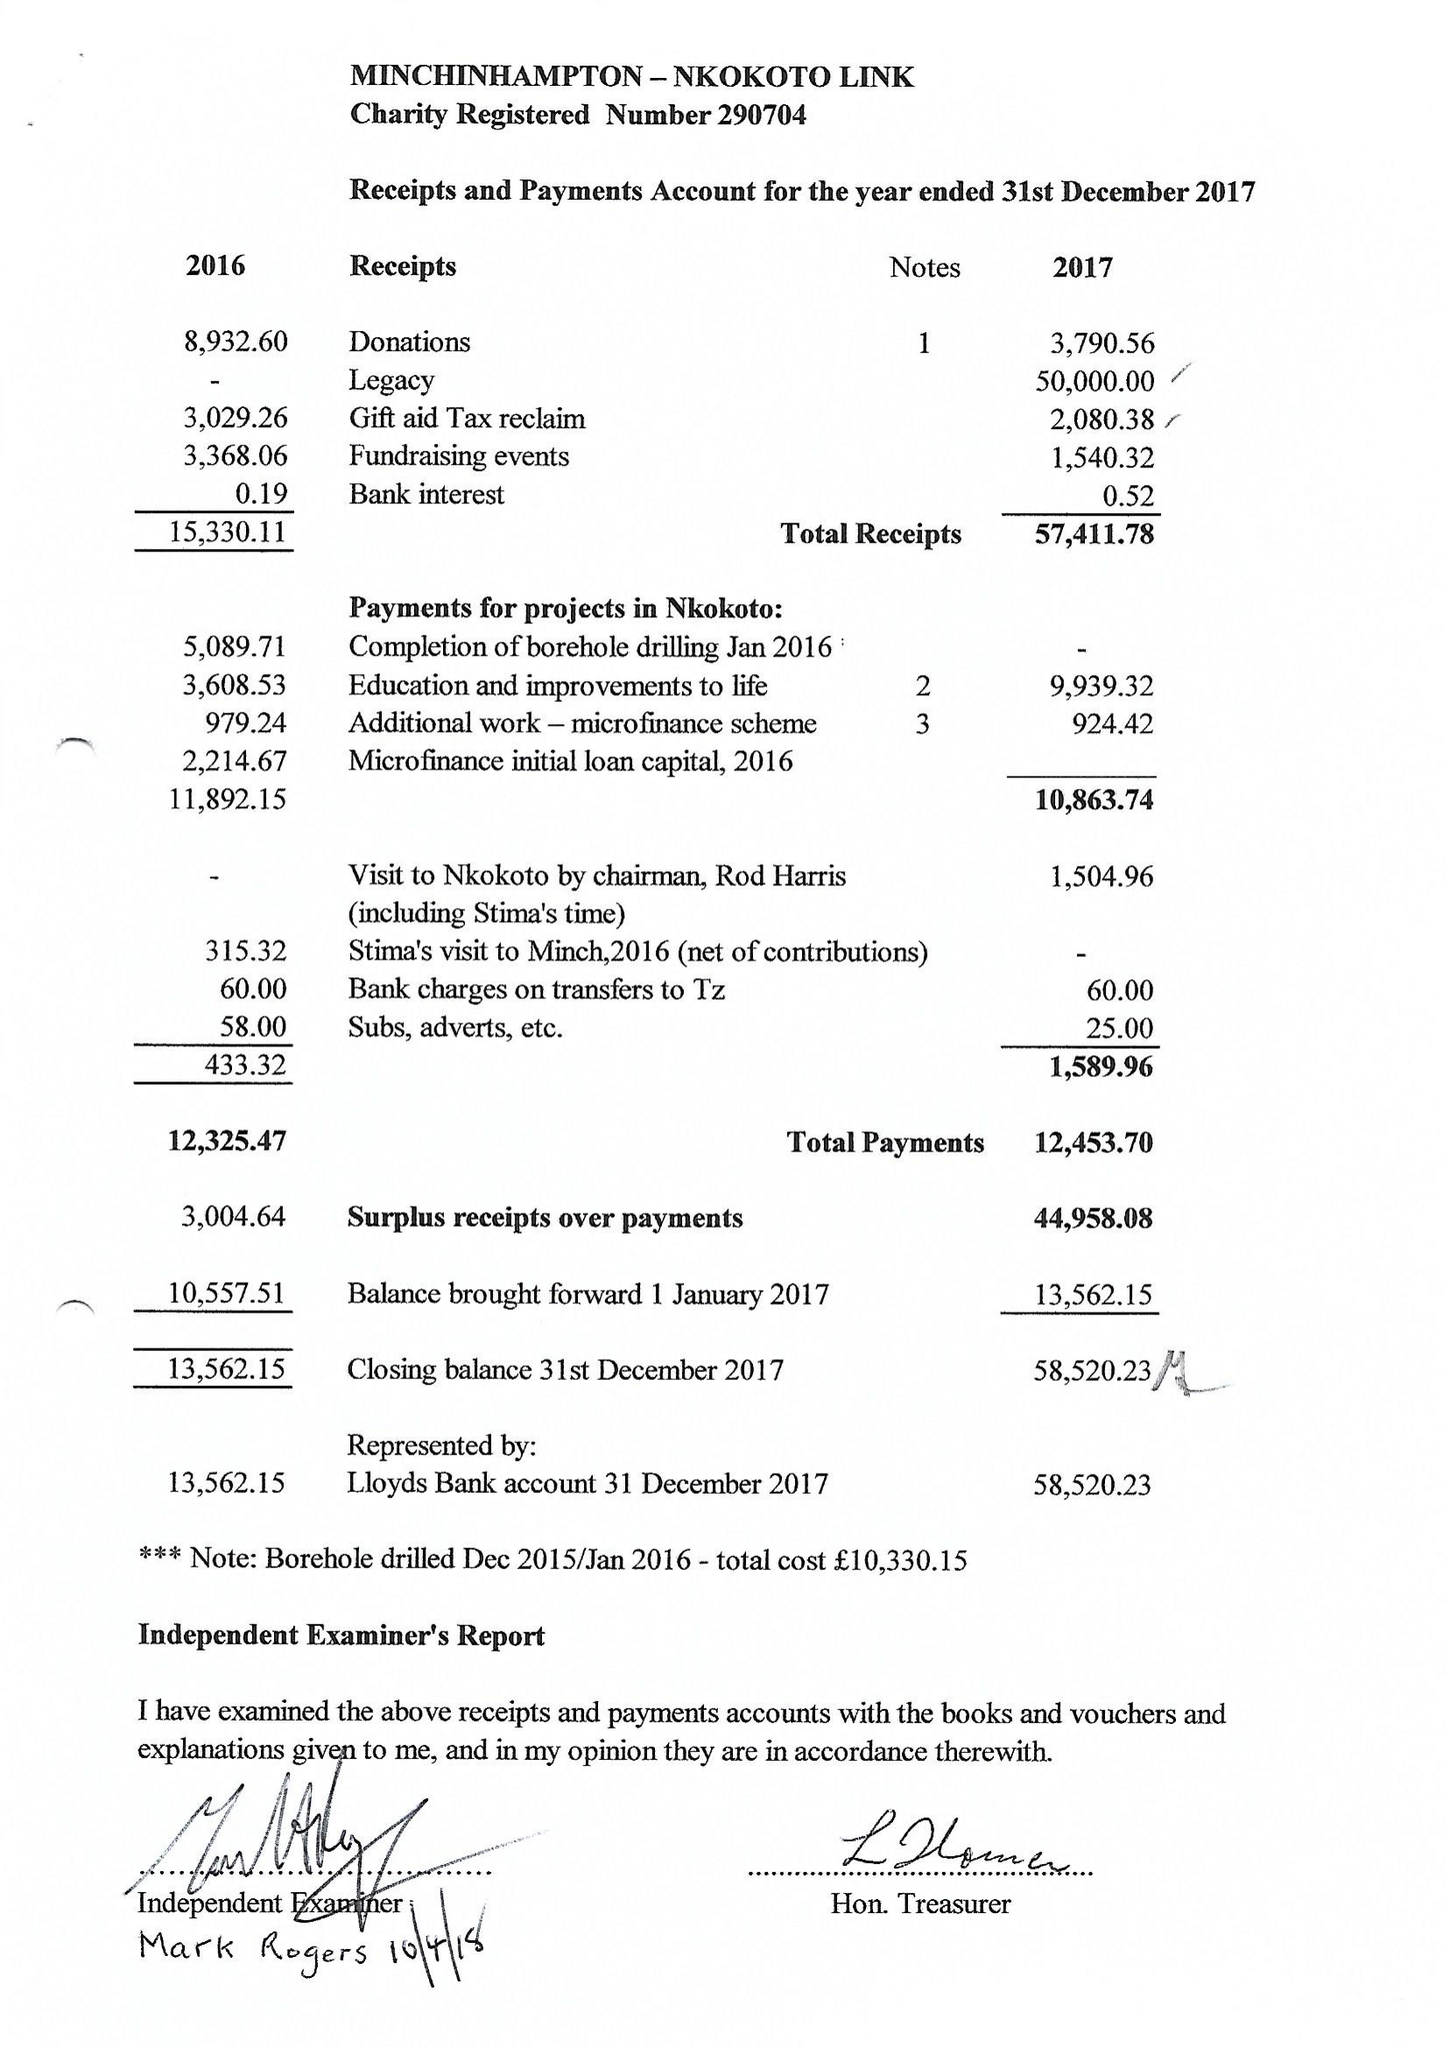What is the value for the charity_name?
Answer the question using a single word or phrase. The Minchinhampton - Nkokoto Link 